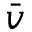Convert formula to latex. <formula><loc_0><loc_0><loc_500><loc_500>\bar { v }</formula> 